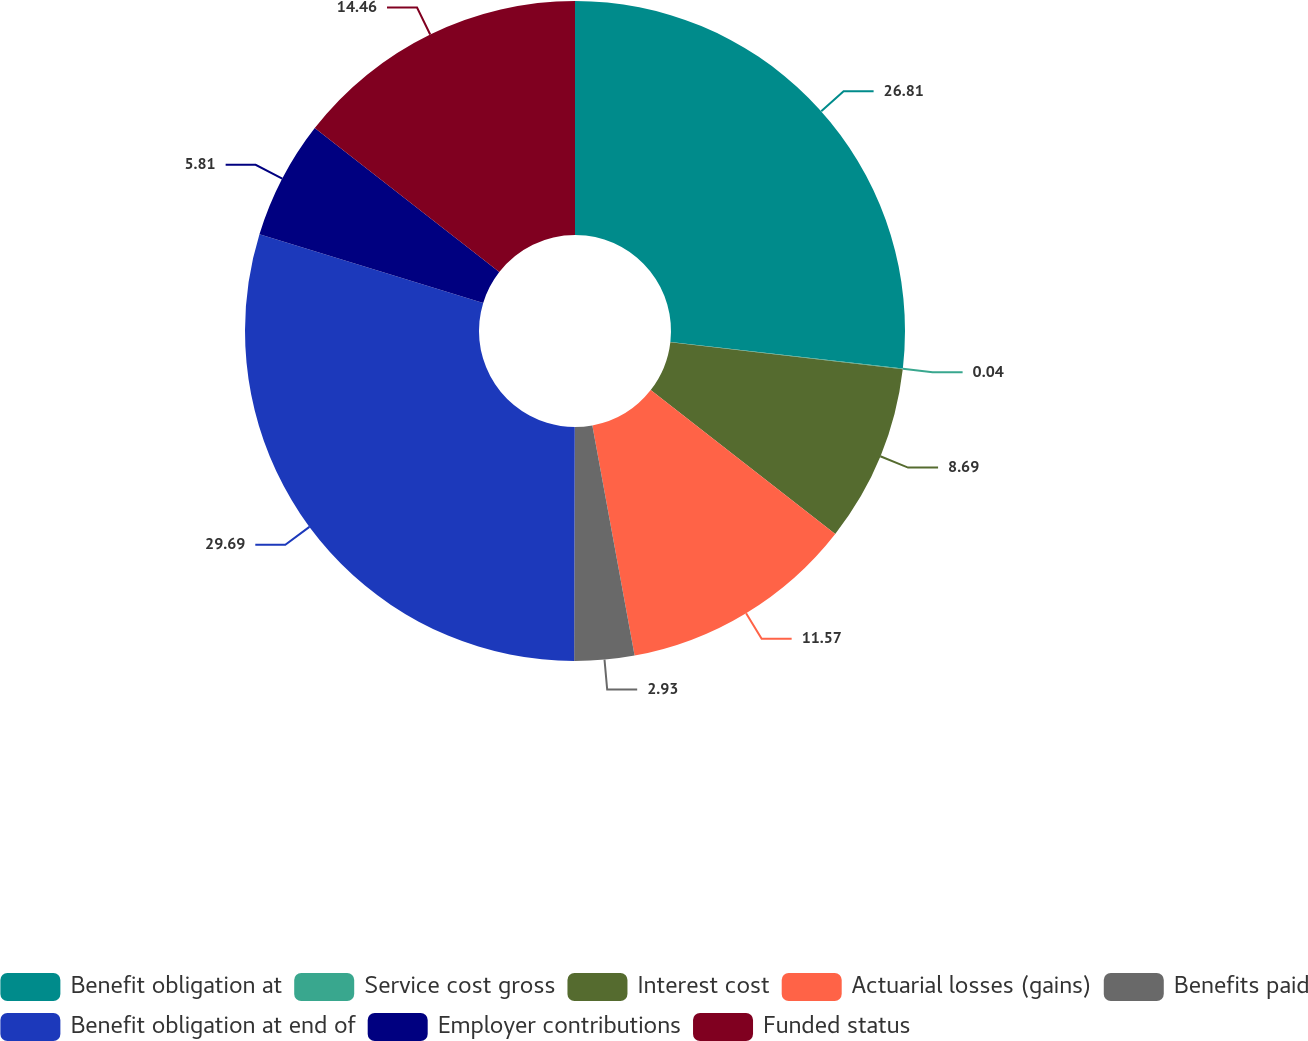Convert chart to OTSL. <chart><loc_0><loc_0><loc_500><loc_500><pie_chart><fcel>Benefit obligation at<fcel>Service cost gross<fcel>Interest cost<fcel>Actuarial losses (gains)<fcel>Benefits paid<fcel>Benefit obligation at end of<fcel>Employer contributions<fcel>Funded status<nl><fcel>26.81%<fcel>0.04%<fcel>8.69%<fcel>11.57%<fcel>2.93%<fcel>29.69%<fcel>5.81%<fcel>14.46%<nl></chart> 